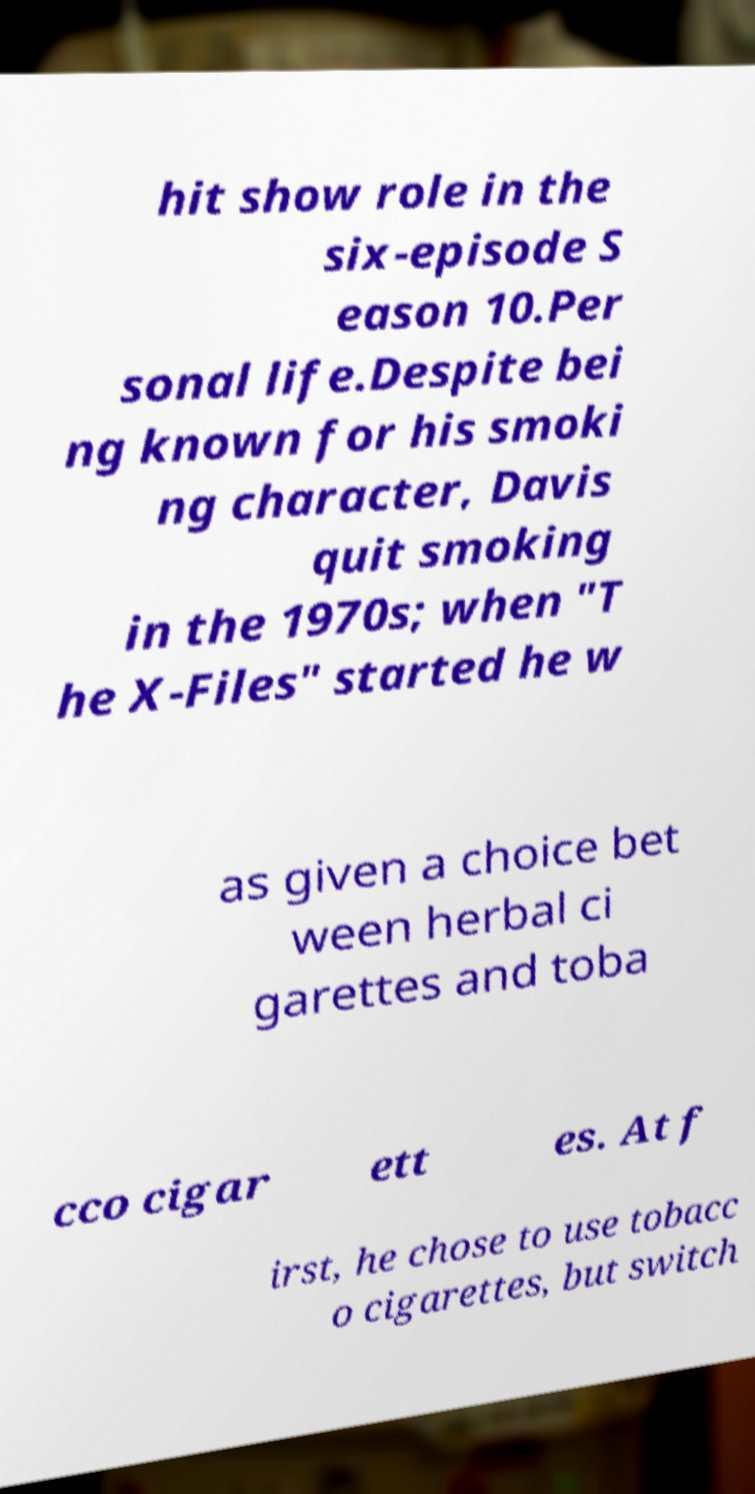Could you assist in decoding the text presented in this image and type it out clearly? hit show role in the six-episode S eason 10.Per sonal life.Despite bei ng known for his smoki ng character, Davis quit smoking in the 1970s; when "T he X-Files" started he w as given a choice bet ween herbal ci garettes and toba cco cigar ett es. At f irst, he chose to use tobacc o cigarettes, but switch 